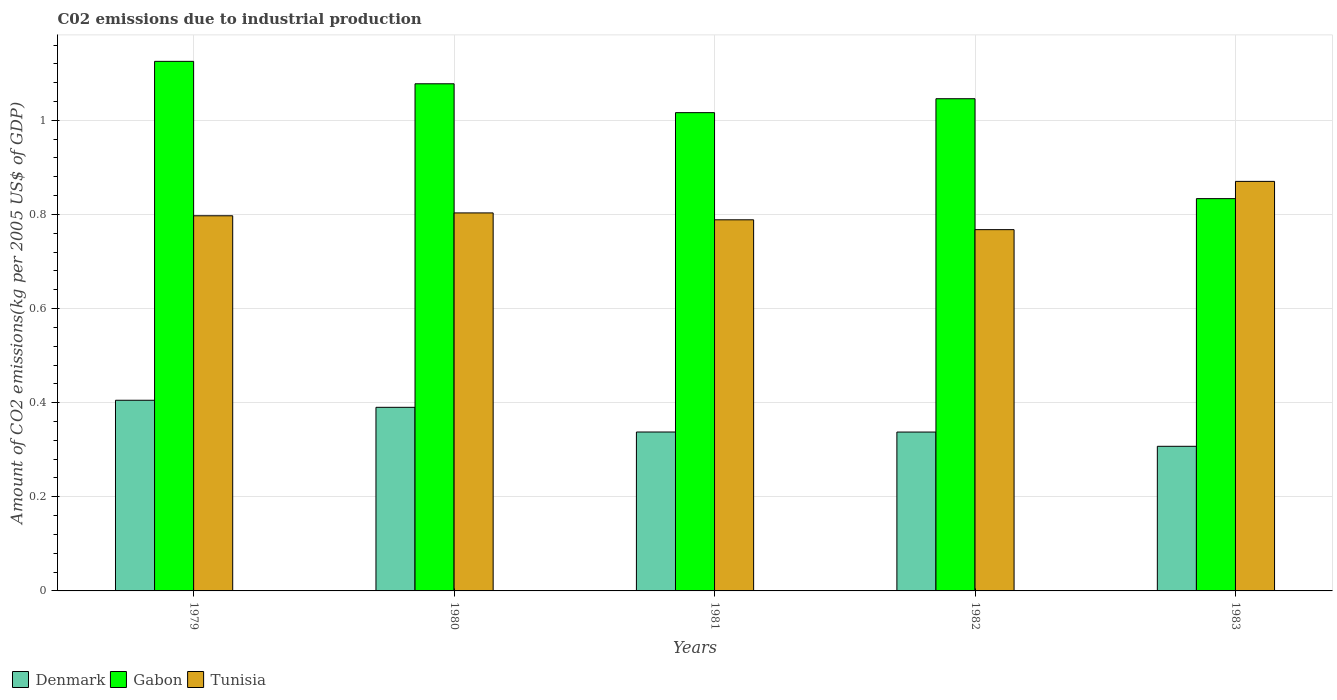In how many cases, is the number of bars for a given year not equal to the number of legend labels?
Ensure brevity in your answer.  0. What is the amount of CO2 emitted due to industrial production in Gabon in 1980?
Make the answer very short. 1.08. Across all years, what is the maximum amount of CO2 emitted due to industrial production in Gabon?
Provide a succinct answer. 1.13. Across all years, what is the minimum amount of CO2 emitted due to industrial production in Tunisia?
Provide a short and direct response. 0.77. In which year was the amount of CO2 emitted due to industrial production in Denmark maximum?
Your answer should be compact. 1979. In which year was the amount of CO2 emitted due to industrial production in Tunisia minimum?
Your answer should be very brief. 1982. What is the total amount of CO2 emitted due to industrial production in Gabon in the graph?
Offer a terse response. 5.1. What is the difference between the amount of CO2 emitted due to industrial production in Denmark in 1980 and that in 1983?
Your answer should be very brief. 0.08. What is the difference between the amount of CO2 emitted due to industrial production in Gabon in 1980 and the amount of CO2 emitted due to industrial production in Denmark in 1979?
Make the answer very short. 0.67. What is the average amount of CO2 emitted due to industrial production in Gabon per year?
Keep it short and to the point. 1.02. In the year 1983, what is the difference between the amount of CO2 emitted due to industrial production in Denmark and amount of CO2 emitted due to industrial production in Gabon?
Offer a very short reply. -0.53. In how many years, is the amount of CO2 emitted due to industrial production in Denmark greater than 0.6400000000000001 kg?
Your response must be concise. 0. What is the ratio of the amount of CO2 emitted due to industrial production in Denmark in 1980 to that in 1981?
Provide a short and direct response. 1.16. Is the difference between the amount of CO2 emitted due to industrial production in Denmark in 1979 and 1983 greater than the difference between the amount of CO2 emitted due to industrial production in Gabon in 1979 and 1983?
Make the answer very short. No. What is the difference between the highest and the second highest amount of CO2 emitted due to industrial production in Denmark?
Your response must be concise. 0.02. What is the difference between the highest and the lowest amount of CO2 emitted due to industrial production in Gabon?
Your answer should be compact. 0.29. Is the sum of the amount of CO2 emitted due to industrial production in Denmark in 1979 and 1981 greater than the maximum amount of CO2 emitted due to industrial production in Gabon across all years?
Offer a very short reply. No. What does the 2nd bar from the left in 1979 represents?
Your answer should be compact. Gabon. What does the 1st bar from the right in 1979 represents?
Make the answer very short. Tunisia. Is it the case that in every year, the sum of the amount of CO2 emitted due to industrial production in Tunisia and amount of CO2 emitted due to industrial production in Gabon is greater than the amount of CO2 emitted due to industrial production in Denmark?
Offer a very short reply. Yes. Does the graph contain any zero values?
Offer a very short reply. No. Does the graph contain grids?
Provide a succinct answer. Yes. Where does the legend appear in the graph?
Keep it short and to the point. Bottom left. What is the title of the graph?
Offer a very short reply. C02 emissions due to industrial production. What is the label or title of the X-axis?
Make the answer very short. Years. What is the label or title of the Y-axis?
Your answer should be very brief. Amount of CO2 emissions(kg per 2005 US$ of GDP). What is the Amount of CO2 emissions(kg per 2005 US$ of GDP) of Denmark in 1979?
Your answer should be very brief. 0.41. What is the Amount of CO2 emissions(kg per 2005 US$ of GDP) in Gabon in 1979?
Provide a succinct answer. 1.13. What is the Amount of CO2 emissions(kg per 2005 US$ of GDP) in Tunisia in 1979?
Ensure brevity in your answer.  0.8. What is the Amount of CO2 emissions(kg per 2005 US$ of GDP) of Denmark in 1980?
Keep it short and to the point. 0.39. What is the Amount of CO2 emissions(kg per 2005 US$ of GDP) of Gabon in 1980?
Provide a short and direct response. 1.08. What is the Amount of CO2 emissions(kg per 2005 US$ of GDP) in Tunisia in 1980?
Keep it short and to the point. 0.8. What is the Amount of CO2 emissions(kg per 2005 US$ of GDP) of Denmark in 1981?
Offer a very short reply. 0.34. What is the Amount of CO2 emissions(kg per 2005 US$ of GDP) of Gabon in 1981?
Offer a very short reply. 1.02. What is the Amount of CO2 emissions(kg per 2005 US$ of GDP) of Tunisia in 1981?
Offer a terse response. 0.79. What is the Amount of CO2 emissions(kg per 2005 US$ of GDP) in Denmark in 1982?
Give a very brief answer. 0.34. What is the Amount of CO2 emissions(kg per 2005 US$ of GDP) of Gabon in 1982?
Keep it short and to the point. 1.05. What is the Amount of CO2 emissions(kg per 2005 US$ of GDP) in Tunisia in 1982?
Offer a terse response. 0.77. What is the Amount of CO2 emissions(kg per 2005 US$ of GDP) of Denmark in 1983?
Give a very brief answer. 0.31. What is the Amount of CO2 emissions(kg per 2005 US$ of GDP) in Gabon in 1983?
Provide a succinct answer. 0.83. What is the Amount of CO2 emissions(kg per 2005 US$ of GDP) of Tunisia in 1983?
Your answer should be very brief. 0.87. Across all years, what is the maximum Amount of CO2 emissions(kg per 2005 US$ of GDP) in Denmark?
Make the answer very short. 0.41. Across all years, what is the maximum Amount of CO2 emissions(kg per 2005 US$ of GDP) of Gabon?
Your response must be concise. 1.13. Across all years, what is the maximum Amount of CO2 emissions(kg per 2005 US$ of GDP) of Tunisia?
Keep it short and to the point. 0.87. Across all years, what is the minimum Amount of CO2 emissions(kg per 2005 US$ of GDP) in Denmark?
Ensure brevity in your answer.  0.31. Across all years, what is the minimum Amount of CO2 emissions(kg per 2005 US$ of GDP) in Gabon?
Your response must be concise. 0.83. Across all years, what is the minimum Amount of CO2 emissions(kg per 2005 US$ of GDP) of Tunisia?
Provide a succinct answer. 0.77. What is the total Amount of CO2 emissions(kg per 2005 US$ of GDP) in Denmark in the graph?
Your answer should be compact. 1.78. What is the total Amount of CO2 emissions(kg per 2005 US$ of GDP) in Gabon in the graph?
Make the answer very short. 5.1. What is the total Amount of CO2 emissions(kg per 2005 US$ of GDP) in Tunisia in the graph?
Give a very brief answer. 4.03. What is the difference between the Amount of CO2 emissions(kg per 2005 US$ of GDP) in Denmark in 1979 and that in 1980?
Provide a succinct answer. 0.01. What is the difference between the Amount of CO2 emissions(kg per 2005 US$ of GDP) in Gabon in 1979 and that in 1980?
Offer a very short reply. 0.05. What is the difference between the Amount of CO2 emissions(kg per 2005 US$ of GDP) of Tunisia in 1979 and that in 1980?
Make the answer very short. -0.01. What is the difference between the Amount of CO2 emissions(kg per 2005 US$ of GDP) in Denmark in 1979 and that in 1981?
Your response must be concise. 0.07. What is the difference between the Amount of CO2 emissions(kg per 2005 US$ of GDP) in Gabon in 1979 and that in 1981?
Your answer should be compact. 0.11. What is the difference between the Amount of CO2 emissions(kg per 2005 US$ of GDP) of Tunisia in 1979 and that in 1981?
Make the answer very short. 0.01. What is the difference between the Amount of CO2 emissions(kg per 2005 US$ of GDP) of Denmark in 1979 and that in 1982?
Offer a very short reply. 0.07. What is the difference between the Amount of CO2 emissions(kg per 2005 US$ of GDP) in Gabon in 1979 and that in 1982?
Give a very brief answer. 0.08. What is the difference between the Amount of CO2 emissions(kg per 2005 US$ of GDP) of Tunisia in 1979 and that in 1982?
Your answer should be very brief. 0.03. What is the difference between the Amount of CO2 emissions(kg per 2005 US$ of GDP) in Denmark in 1979 and that in 1983?
Your answer should be very brief. 0.1. What is the difference between the Amount of CO2 emissions(kg per 2005 US$ of GDP) of Gabon in 1979 and that in 1983?
Give a very brief answer. 0.29. What is the difference between the Amount of CO2 emissions(kg per 2005 US$ of GDP) in Tunisia in 1979 and that in 1983?
Ensure brevity in your answer.  -0.07. What is the difference between the Amount of CO2 emissions(kg per 2005 US$ of GDP) in Denmark in 1980 and that in 1981?
Keep it short and to the point. 0.05. What is the difference between the Amount of CO2 emissions(kg per 2005 US$ of GDP) in Gabon in 1980 and that in 1981?
Your response must be concise. 0.06. What is the difference between the Amount of CO2 emissions(kg per 2005 US$ of GDP) of Tunisia in 1980 and that in 1981?
Ensure brevity in your answer.  0.01. What is the difference between the Amount of CO2 emissions(kg per 2005 US$ of GDP) in Denmark in 1980 and that in 1982?
Offer a very short reply. 0.05. What is the difference between the Amount of CO2 emissions(kg per 2005 US$ of GDP) of Gabon in 1980 and that in 1982?
Give a very brief answer. 0.03. What is the difference between the Amount of CO2 emissions(kg per 2005 US$ of GDP) in Tunisia in 1980 and that in 1982?
Your response must be concise. 0.04. What is the difference between the Amount of CO2 emissions(kg per 2005 US$ of GDP) in Denmark in 1980 and that in 1983?
Provide a succinct answer. 0.08. What is the difference between the Amount of CO2 emissions(kg per 2005 US$ of GDP) in Gabon in 1980 and that in 1983?
Offer a very short reply. 0.24. What is the difference between the Amount of CO2 emissions(kg per 2005 US$ of GDP) in Tunisia in 1980 and that in 1983?
Your response must be concise. -0.07. What is the difference between the Amount of CO2 emissions(kg per 2005 US$ of GDP) in Denmark in 1981 and that in 1982?
Offer a terse response. 0. What is the difference between the Amount of CO2 emissions(kg per 2005 US$ of GDP) of Gabon in 1981 and that in 1982?
Provide a succinct answer. -0.03. What is the difference between the Amount of CO2 emissions(kg per 2005 US$ of GDP) in Tunisia in 1981 and that in 1982?
Make the answer very short. 0.02. What is the difference between the Amount of CO2 emissions(kg per 2005 US$ of GDP) in Denmark in 1981 and that in 1983?
Your answer should be compact. 0.03. What is the difference between the Amount of CO2 emissions(kg per 2005 US$ of GDP) of Gabon in 1981 and that in 1983?
Keep it short and to the point. 0.18. What is the difference between the Amount of CO2 emissions(kg per 2005 US$ of GDP) of Tunisia in 1981 and that in 1983?
Offer a terse response. -0.08. What is the difference between the Amount of CO2 emissions(kg per 2005 US$ of GDP) of Denmark in 1982 and that in 1983?
Give a very brief answer. 0.03. What is the difference between the Amount of CO2 emissions(kg per 2005 US$ of GDP) of Gabon in 1982 and that in 1983?
Keep it short and to the point. 0.21. What is the difference between the Amount of CO2 emissions(kg per 2005 US$ of GDP) in Tunisia in 1982 and that in 1983?
Your answer should be very brief. -0.1. What is the difference between the Amount of CO2 emissions(kg per 2005 US$ of GDP) of Denmark in 1979 and the Amount of CO2 emissions(kg per 2005 US$ of GDP) of Gabon in 1980?
Provide a short and direct response. -0.67. What is the difference between the Amount of CO2 emissions(kg per 2005 US$ of GDP) of Denmark in 1979 and the Amount of CO2 emissions(kg per 2005 US$ of GDP) of Tunisia in 1980?
Offer a terse response. -0.4. What is the difference between the Amount of CO2 emissions(kg per 2005 US$ of GDP) in Gabon in 1979 and the Amount of CO2 emissions(kg per 2005 US$ of GDP) in Tunisia in 1980?
Offer a very short reply. 0.32. What is the difference between the Amount of CO2 emissions(kg per 2005 US$ of GDP) in Denmark in 1979 and the Amount of CO2 emissions(kg per 2005 US$ of GDP) in Gabon in 1981?
Your answer should be very brief. -0.61. What is the difference between the Amount of CO2 emissions(kg per 2005 US$ of GDP) of Denmark in 1979 and the Amount of CO2 emissions(kg per 2005 US$ of GDP) of Tunisia in 1981?
Your answer should be compact. -0.38. What is the difference between the Amount of CO2 emissions(kg per 2005 US$ of GDP) in Gabon in 1979 and the Amount of CO2 emissions(kg per 2005 US$ of GDP) in Tunisia in 1981?
Provide a short and direct response. 0.34. What is the difference between the Amount of CO2 emissions(kg per 2005 US$ of GDP) of Denmark in 1979 and the Amount of CO2 emissions(kg per 2005 US$ of GDP) of Gabon in 1982?
Your answer should be very brief. -0.64. What is the difference between the Amount of CO2 emissions(kg per 2005 US$ of GDP) of Denmark in 1979 and the Amount of CO2 emissions(kg per 2005 US$ of GDP) of Tunisia in 1982?
Keep it short and to the point. -0.36. What is the difference between the Amount of CO2 emissions(kg per 2005 US$ of GDP) in Gabon in 1979 and the Amount of CO2 emissions(kg per 2005 US$ of GDP) in Tunisia in 1982?
Make the answer very short. 0.36. What is the difference between the Amount of CO2 emissions(kg per 2005 US$ of GDP) in Denmark in 1979 and the Amount of CO2 emissions(kg per 2005 US$ of GDP) in Gabon in 1983?
Keep it short and to the point. -0.43. What is the difference between the Amount of CO2 emissions(kg per 2005 US$ of GDP) of Denmark in 1979 and the Amount of CO2 emissions(kg per 2005 US$ of GDP) of Tunisia in 1983?
Provide a succinct answer. -0.47. What is the difference between the Amount of CO2 emissions(kg per 2005 US$ of GDP) of Gabon in 1979 and the Amount of CO2 emissions(kg per 2005 US$ of GDP) of Tunisia in 1983?
Keep it short and to the point. 0.26. What is the difference between the Amount of CO2 emissions(kg per 2005 US$ of GDP) of Denmark in 1980 and the Amount of CO2 emissions(kg per 2005 US$ of GDP) of Gabon in 1981?
Provide a short and direct response. -0.63. What is the difference between the Amount of CO2 emissions(kg per 2005 US$ of GDP) of Denmark in 1980 and the Amount of CO2 emissions(kg per 2005 US$ of GDP) of Tunisia in 1981?
Your answer should be compact. -0.4. What is the difference between the Amount of CO2 emissions(kg per 2005 US$ of GDP) in Gabon in 1980 and the Amount of CO2 emissions(kg per 2005 US$ of GDP) in Tunisia in 1981?
Offer a very short reply. 0.29. What is the difference between the Amount of CO2 emissions(kg per 2005 US$ of GDP) of Denmark in 1980 and the Amount of CO2 emissions(kg per 2005 US$ of GDP) of Gabon in 1982?
Your answer should be very brief. -0.66. What is the difference between the Amount of CO2 emissions(kg per 2005 US$ of GDP) in Denmark in 1980 and the Amount of CO2 emissions(kg per 2005 US$ of GDP) in Tunisia in 1982?
Keep it short and to the point. -0.38. What is the difference between the Amount of CO2 emissions(kg per 2005 US$ of GDP) of Gabon in 1980 and the Amount of CO2 emissions(kg per 2005 US$ of GDP) of Tunisia in 1982?
Offer a very short reply. 0.31. What is the difference between the Amount of CO2 emissions(kg per 2005 US$ of GDP) of Denmark in 1980 and the Amount of CO2 emissions(kg per 2005 US$ of GDP) of Gabon in 1983?
Ensure brevity in your answer.  -0.44. What is the difference between the Amount of CO2 emissions(kg per 2005 US$ of GDP) of Denmark in 1980 and the Amount of CO2 emissions(kg per 2005 US$ of GDP) of Tunisia in 1983?
Give a very brief answer. -0.48. What is the difference between the Amount of CO2 emissions(kg per 2005 US$ of GDP) of Gabon in 1980 and the Amount of CO2 emissions(kg per 2005 US$ of GDP) of Tunisia in 1983?
Provide a succinct answer. 0.21. What is the difference between the Amount of CO2 emissions(kg per 2005 US$ of GDP) of Denmark in 1981 and the Amount of CO2 emissions(kg per 2005 US$ of GDP) of Gabon in 1982?
Offer a very short reply. -0.71. What is the difference between the Amount of CO2 emissions(kg per 2005 US$ of GDP) in Denmark in 1981 and the Amount of CO2 emissions(kg per 2005 US$ of GDP) in Tunisia in 1982?
Your response must be concise. -0.43. What is the difference between the Amount of CO2 emissions(kg per 2005 US$ of GDP) in Gabon in 1981 and the Amount of CO2 emissions(kg per 2005 US$ of GDP) in Tunisia in 1982?
Ensure brevity in your answer.  0.25. What is the difference between the Amount of CO2 emissions(kg per 2005 US$ of GDP) of Denmark in 1981 and the Amount of CO2 emissions(kg per 2005 US$ of GDP) of Gabon in 1983?
Provide a succinct answer. -0.5. What is the difference between the Amount of CO2 emissions(kg per 2005 US$ of GDP) in Denmark in 1981 and the Amount of CO2 emissions(kg per 2005 US$ of GDP) in Tunisia in 1983?
Offer a very short reply. -0.53. What is the difference between the Amount of CO2 emissions(kg per 2005 US$ of GDP) in Gabon in 1981 and the Amount of CO2 emissions(kg per 2005 US$ of GDP) in Tunisia in 1983?
Give a very brief answer. 0.15. What is the difference between the Amount of CO2 emissions(kg per 2005 US$ of GDP) in Denmark in 1982 and the Amount of CO2 emissions(kg per 2005 US$ of GDP) in Gabon in 1983?
Make the answer very short. -0.5. What is the difference between the Amount of CO2 emissions(kg per 2005 US$ of GDP) of Denmark in 1982 and the Amount of CO2 emissions(kg per 2005 US$ of GDP) of Tunisia in 1983?
Your answer should be compact. -0.53. What is the difference between the Amount of CO2 emissions(kg per 2005 US$ of GDP) in Gabon in 1982 and the Amount of CO2 emissions(kg per 2005 US$ of GDP) in Tunisia in 1983?
Your response must be concise. 0.18. What is the average Amount of CO2 emissions(kg per 2005 US$ of GDP) in Denmark per year?
Make the answer very short. 0.36. What is the average Amount of CO2 emissions(kg per 2005 US$ of GDP) in Gabon per year?
Your answer should be compact. 1.02. What is the average Amount of CO2 emissions(kg per 2005 US$ of GDP) of Tunisia per year?
Your answer should be very brief. 0.81. In the year 1979, what is the difference between the Amount of CO2 emissions(kg per 2005 US$ of GDP) of Denmark and Amount of CO2 emissions(kg per 2005 US$ of GDP) of Gabon?
Ensure brevity in your answer.  -0.72. In the year 1979, what is the difference between the Amount of CO2 emissions(kg per 2005 US$ of GDP) in Denmark and Amount of CO2 emissions(kg per 2005 US$ of GDP) in Tunisia?
Provide a succinct answer. -0.39. In the year 1979, what is the difference between the Amount of CO2 emissions(kg per 2005 US$ of GDP) of Gabon and Amount of CO2 emissions(kg per 2005 US$ of GDP) of Tunisia?
Provide a short and direct response. 0.33. In the year 1980, what is the difference between the Amount of CO2 emissions(kg per 2005 US$ of GDP) of Denmark and Amount of CO2 emissions(kg per 2005 US$ of GDP) of Gabon?
Make the answer very short. -0.69. In the year 1980, what is the difference between the Amount of CO2 emissions(kg per 2005 US$ of GDP) in Denmark and Amount of CO2 emissions(kg per 2005 US$ of GDP) in Tunisia?
Offer a very short reply. -0.41. In the year 1980, what is the difference between the Amount of CO2 emissions(kg per 2005 US$ of GDP) of Gabon and Amount of CO2 emissions(kg per 2005 US$ of GDP) of Tunisia?
Your response must be concise. 0.27. In the year 1981, what is the difference between the Amount of CO2 emissions(kg per 2005 US$ of GDP) of Denmark and Amount of CO2 emissions(kg per 2005 US$ of GDP) of Gabon?
Provide a succinct answer. -0.68. In the year 1981, what is the difference between the Amount of CO2 emissions(kg per 2005 US$ of GDP) of Denmark and Amount of CO2 emissions(kg per 2005 US$ of GDP) of Tunisia?
Ensure brevity in your answer.  -0.45. In the year 1981, what is the difference between the Amount of CO2 emissions(kg per 2005 US$ of GDP) of Gabon and Amount of CO2 emissions(kg per 2005 US$ of GDP) of Tunisia?
Make the answer very short. 0.23. In the year 1982, what is the difference between the Amount of CO2 emissions(kg per 2005 US$ of GDP) in Denmark and Amount of CO2 emissions(kg per 2005 US$ of GDP) in Gabon?
Give a very brief answer. -0.71. In the year 1982, what is the difference between the Amount of CO2 emissions(kg per 2005 US$ of GDP) of Denmark and Amount of CO2 emissions(kg per 2005 US$ of GDP) of Tunisia?
Keep it short and to the point. -0.43. In the year 1982, what is the difference between the Amount of CO2 emissions(kg per 2005 US$ of GDP) in Gabon and Amount of CO2 emissions(kg per 2005 US$ of GDP) in Tunisia?
Offer a very short reply. 0.28. In the year 1983, what is the difference between the Amount of CO2 emissions(kg per 2005 US$ of GDP) in Denmark and Amount of CO2 emissions(kg per 2005 US$ of GDP) in Gabon?
Ensure brevity in your answer.  -0.53. In the year 1983, what is the difference between the Amount of CO2 emissions(kg per 2005 US$ of GDP) of Denmark and Amount of CO2 emissions(kg per 2005 US$ of GDP) of Tunisia?
Keep it short and to the point. -0.56. In the year 1983, what is the difference between the Amount of CO2 emissions(kg per 2005 US$ of GDP) in Gabon and Amount of CO2 emissions(kg per 2005 US$ of GDP) in Tunisia?
Offer a very short reply. -0.04. What is the ratio of the Amount of CO2 emissions(kg per 2005 US$ of GDP) of Denmark in 1979 to that in 1980?
Your answer should be compact. 1.04. What is the ratio of the Amount of CO2 emissions(kg per 2005 US$ of GDP) in Gabon in 1979 to that in 1980?
Keep it short and to the point. 1.04. What is the ratio of the Amount of CO2 emissions(kg per 2005 US$ of GDP) of Denmark in 1979 to that in 1981?
Make the answer very short. 1.2. What is the ratio of the Amount of CO2 emissions(kg per 2005 US$ of GDP) of Gabon in 1979 to that in 1981?
Provide a succinct answer. 1.11. What is the ratio of the Amount of CO2 emissions(kg per 2005 US$ of GDP) of Tunisia in 1979 to that in 1981?
Your answer should be very brief. 1.01. What is the ratio of the Amount of CO2 emissions(kg per 2005 US$ of GDP) in Denmark in 1979 to that in 1982?
Your answer should be very brief. 1.2. What is the ratio of the Amount of CO2 emissions(kg per 2005 US$ of GDP) of Gabon in 1979 to that in 1982?
Provide a succinct answer. 1.08. What is the ratio of the Amount of CO2 emissions(kg per 2005 US$ of GDP) in Tunisia in 1979 to that in 1982?
Your answer should be compact. 1.04. What is the ratio of the Amount of CO2 emissions(kg per 2005 US$ of GDP) in Denmark in 1979 to that in 1983?
Your response must be concise. 1.32. What is the ratio of the Amount of CO2 emissions(kg per 2005 US$ of GDP) of Gabon in 1979 to that in 1983?
Make the answer very short. 1.35. What is the ratio of the Amount of CO2 emissions(kg per 2005 US$ of GDP) of Tunisia in 1979 to that in 1983?
Provide a short and direct response. 0.92. What is the ratio of the Amount of CO2 emissions(kg per 2005 US$ of GDP) in Denmark in 1980 to that in 1981?
Ensure brevity in your answer.  1.16. What is the ratio of the Amount of CO2 emissions(kg per 2005 US$ of GDP) of Gabon in 1980 to that in 1981?
Ensure brevity in your answer.  1.06. What is the ratio of the Amount of CO2 emissions(kg per 2005 US$ of GDP) of Tunisia in 1980 to that in 1981?
Give a very brief answer. 1.02. What is the ratio of the Amount of CO2 emissions(kg per 2005 US$ of GDP) of Denmark in 1980 to that in 1982?
Offer a terse response. 1.16. What is the ratio of the Amount of CO2 emissions(kg per 2005 US$ of GDP) in Gabon in 1980 to that in 1982?
Ensure brevity in your answer.  1.03. What is the ratio of the Amount of CO2 emissions(kg per 2005 US$ of GDP) in Tunisia in 1980 to that in 1982?
Ensure brevity in your answer.  1.05. What is the ratio of the Amount of CO2 emissions(kg per 2005 US$ of GDP) in Denmark in 1980 to that in 1983?
Your response must be concise. 1.27. What is the ratio of the Amount of CO2 emissions(kg per 2005 US$ of GDP) in Gabon in 1980 to that in 1983?
Give a very brief answer. 1.29. What is the ratio of the Amount of CO2 emissions(kg per 2005 US$ of GDP) in Tunisia in 1980 to that in 1983?
Keep it short and to the point. 0.92. What is the ratio of the Amount of CO2 emissions(kg per 2005 US$ of GDP) of Denmark in 1981 to that in 1982?
Provide a succinct answer. 1. What is the ratio of the Amount of CO2 emissions(kg per 2005 US$ of GDP) in Gabon in 1981 to that in 1982?
Offer a terse response. 0.97. What is the ratio of the Amount of CO2 emissions(kg per 2005 US$ of GDP) of Tunisia in 1981 to that in 1982?
Offer a very short reply. 1.03. What is the ratio of the Amount of CO2 emissions(kg per 2005 US$ of GDP) of Denmark in 1981 to that in 1983?
Make the answer very short. 1.1. What is the ratio of the Amount of CO2 emissions(kg per 2005 US$ of GDP) in Gabon in 1981 to that in 1983?
Your answer should be compact. 1.22. What is the ratio of the Amount of CO2 emissions(kg per 2005 US$ of GDP) in Tunisia in 1981 to that in 1983?
Your response must be concise. 0.91. What is the ratio of the Amount of CO2 emissions(kg per 2005 US$ of GDP) in Denmark in 1982 to that in 1983?
Your answer should be compact. 1.1. What is the ratio of the Amount of CO2 emissions(kg per 2005 US$ of GDP) in Gabon in 1982 to that in 1983?
Ensure brevity in your answer.  1.25. What is the ratio of the Amount of CO2 emissions(kg per 2005 US$ of GDP) in Tunisia in 1982 to that in 1983?
Your answer should be compact. 0.88. What is the difference between the highest and the second highest Amount of CO2 emissions(kg per 2005 US$ of GDP) of Denmark?
Keep it short and to the point. 0.01. What is the difference between the highest and the second highest Amount of CO2 emissions(kg per 2005 US$ of GDP) in Gabon?
Offer a very short reply. 0.05. What is the difference between the highest and the second highest Amount of CO2 emissions(kg per 2005 US$ of GDP) in Tunisia?
Provide a short and direct response. 0.07. What is the difference between the highest and the lowest Amount of CO2 emissions(kg per 2005 US$ of GDP) of Denmark?
Keep it short and to the point. 0.1. What is the difference between the highest and the lowest Amount of CO2 emissions(kg per 2005 US$ of GDP) of Gabon?
Your response must be concise. 0.29. What is the difference between the highest and the lowest Amount of CO2 emissions(kg per 2005 US$ of GDP) in Tunisia?
Offer a very short reply. 0.1. 